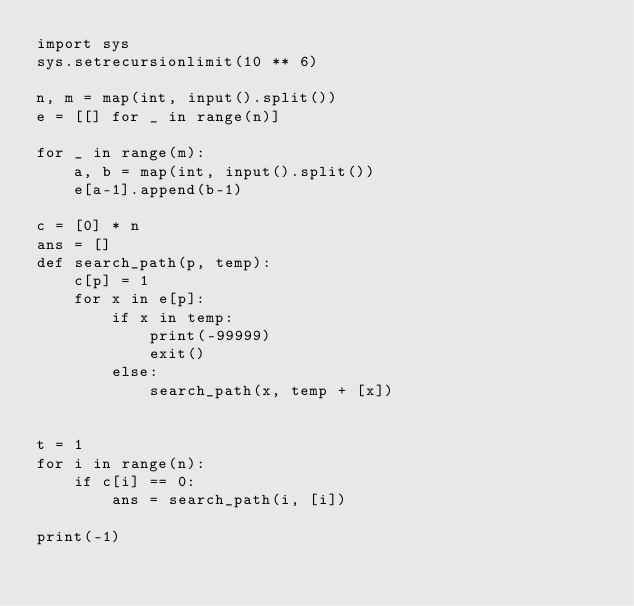<code> <loc_0><loc_0><loc_500><loc_500><_Python_>import sys
sys.setrecursionlimit(10 ** 6)

n, m = map(int, input().split())
e = [[] for _ in range(n)]

for _ in range(m):
    a, b = map(int, input().split())
    e[a-1].append(b-1)

c = [0] * n
ans = []
def search_path(p, temp):
    c[p] = 1
    for x in e[p]:
        if x in temp:
            print(-99999)
            exit()
        else:
            search_path(x, temp + [x])


t = 1
for i in range(n):
    if c[i] == 0:
        ans = search_path(i, [i])

print(-1)
</code> 